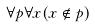Convert formula to latex. <formula><loc_0><loc_0><loc_500><loc_500>\forall p \forall x ( x \notin p )</formula> 